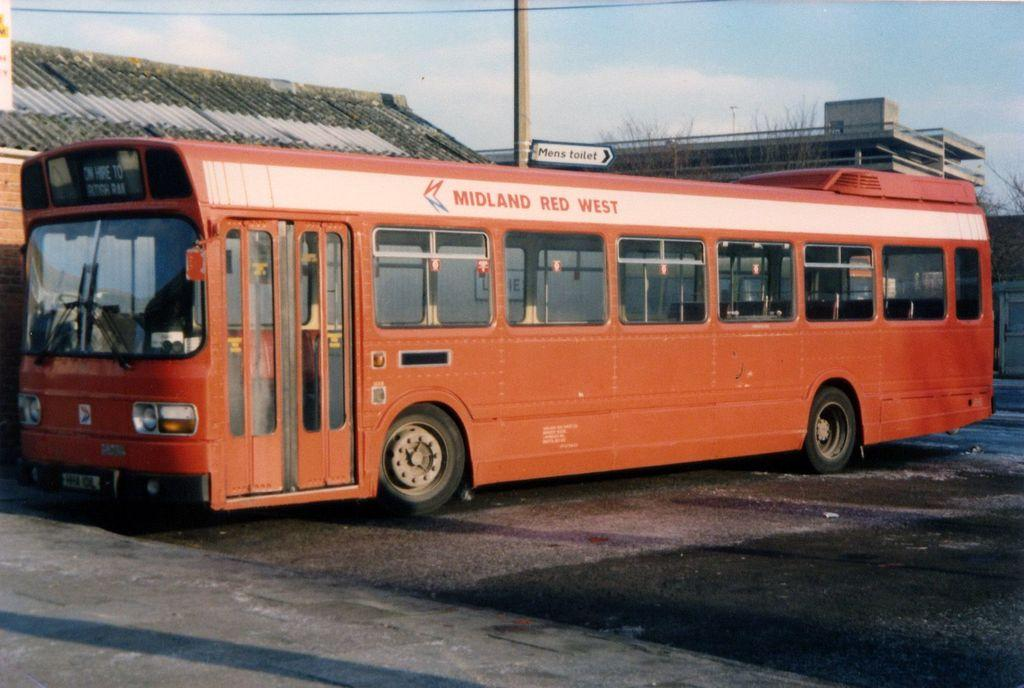What type of vehicle is in the image? There is a red bus in the image. Where is the bus located? The bus is on the road. What words are written on the bus? The words "MIDLAND EAST" are written on the bus. What can be seen in the background of the image? There is a pole in the background of the image. What words are written on the pole? The words "Men's toilet" are written on the pole. What type of loaf is being used as a brick in the image? There is no loaf or brick present in the image; it features a red bus on the road with a pole in the background. 